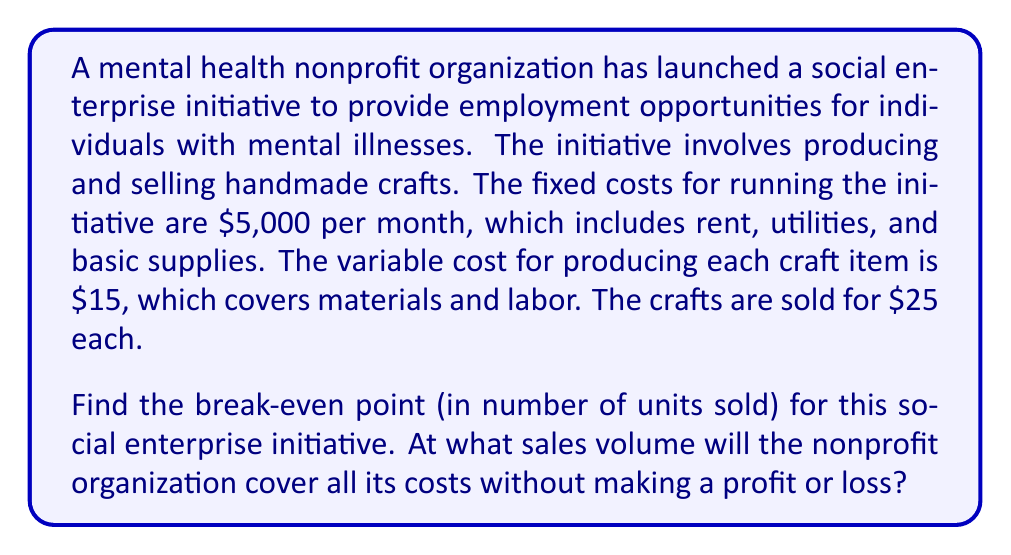Show me your answer to this math problem. To find the break-even point, we need to determine the number of units that must be sold for the total revenue to equal the total costs. Let's approach this step-by-step:

1. Define variables:
   Let $x$ = number of units sold
   
2. Express the total revenue (TR) as a function of $x$:
   $TR = 25x$ (price per unit × number of units)

3. Express the total cost (TC) as a function of $x$:
   $TC = 5000 + 15x$ (fixed costs + variable cost per unit × number of units)

4. At the break-even point, total revenue equals total cost:
   $TR = TC$
   $25x = 5000 + 15x$

5. Solve the equation for $x$:
   $25x - 15x = 5000$
   $10x = 5000$
   $x = 500$

6. Verify:
   At $x = 500$:
   $TR = 25(500) = 12,500$
   $TC = 5000 + 15(500) = 12,500$

Therefore, the break-even point occurs when 500 units are sold.
Answer: The break-even point for the social enterprise initiative is 500 units. 